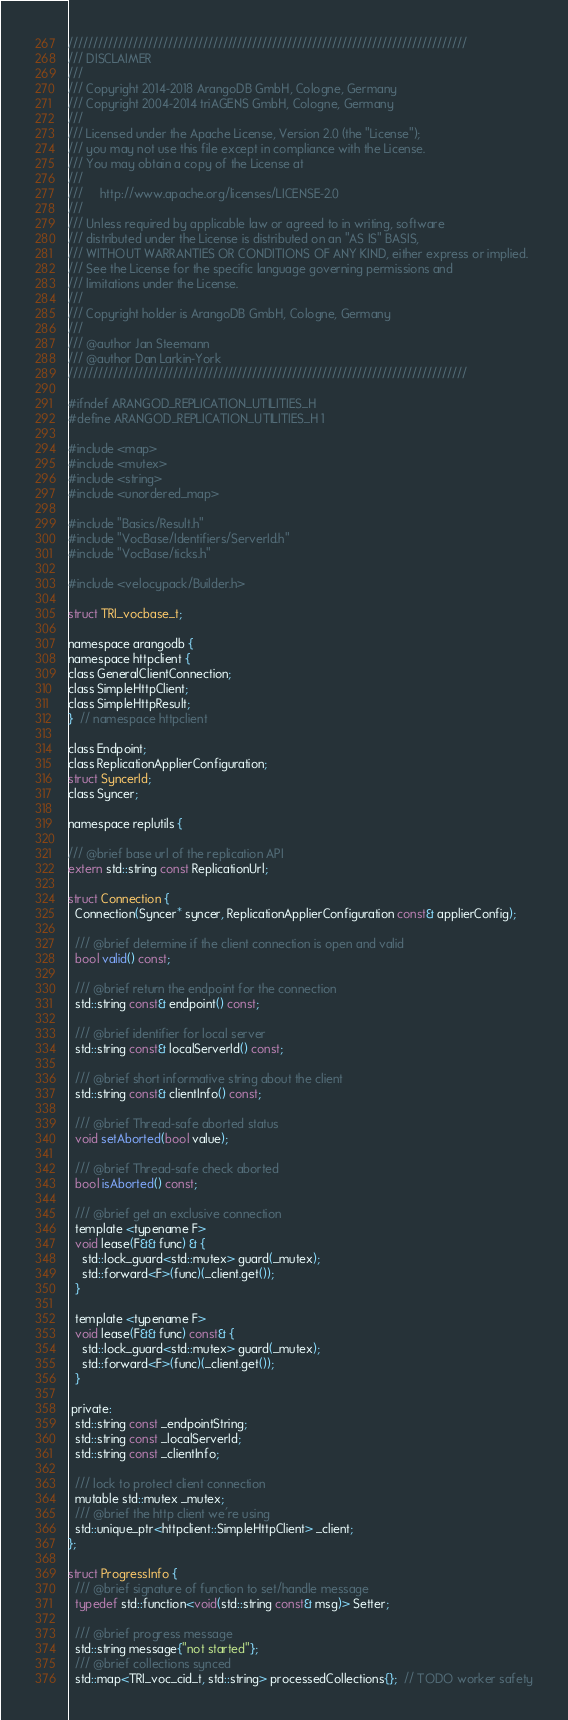Convert code to text. <code><loc_0><loc_0><loc_500><loc_500><_C_>////////////////////////////////////////////////////////////////////////////////
/// DISCLAIMER
///
/// Copyright 2014-2018 ArangoDB GmbH, Cologne, Germany
/// Copyright 2004-2014 triAGENS GmbH, Cologne, Germany
///
/// Licensed under the Apache License, Version 2.0 (the "License");
/// you may not use this file except in compliance with the License.
/// You may obtain a copy of the License at
///
///     http://www.apache.org/licenses/LICENSE-2.0
///
/// Unless required by applicable law or agreed to in writing, software
/// distributed under the License is distributed on an "AS IS" BASIS,
/// WITHOUT WARRANTIES OR CONDITIONS OF ANY KIND, either express or implied.
/// See the License for the specific language governing permissions and
/// limitations under the License.
///
/// Copyright holder is ArangoDB GmbH, Cologne, Germany
///
/// @author Jan Steemann
/// @author Dan Larkin-York
////////////////////////////////////////////////////////////////////////////////

#ifndef ARANGOD_REPLICATION_UTILITIES_H
#define ARANGOD_REPLICATION_UTILITIES_H 1

#include <map>
#include <mutex>
#include <string>
#include <unordered_map>

#include "Basics/Result.h"
#include "VocBase/Identifiers/ServerId.h"
#include "VocBase/ticks.h"

#include <velocypack/Builder.h>

struct TRI_vocbase_t;

namespace arangodb {
namespace httpclient {
class GeneralClientConnection;
class SimpleHttpClient;
class SimpleHttpResult;
}  // namespace httpclient

class Endpoint;
class ReplicationApplierConfiguration;
struct SyncerId;
class Syncer;

namespace replutils {

/// @brief base url of the replication API
extern std::string const ReplicationUrl;

struct Connection {
  Connection(Syncer* syncer, ReplicationApplierConfiguration const& applierConfig);

  /// @brief determine if the client connection is open and valid
  bool valid() const;

  /// @brief return the endpoint for the connection
  std::string const& endpoint() const;

  /// @brief identifier for local server
  std::string const& localServerId() const;

  /// @brief short informative string about the client
  std::string const& clientInfo() const;

  /// @brief Thread-safe aborted status
  void setAborted(bool value);

  /// @brief Thread-safe check aborted
  bool isAborted() const;

  /// @brief get an exclusive connection
  template <typename F>
  void lease(F&& func) & {
    std::lock_guard<std::mutex> guard(_mutex);
    std::forward<F>(func)(_client.get());
  }

  template <typename F>
  void lease(F&& func) const& {
    std::lock_guard<std::mutex> guard(_mutex);
    std::forward<F>(func)(_client.get());
  }

 private:
  std::string const _endpointString;
  std::string const _localServerId;
  std::string const _clientInfo;

  /// lock to protect client connection
  mutable std::mutex _mutex;
  /// @brief the http client we're using
  std::unique_ptr<httpclient::SimpleHttpClient> _client;
};

struct ProgressInfo {
  /// @brief signature of function to set/handle message
  typedef std::function<void(std::string const& msg)> Setter;

  /// @brief progress message
  std::string message{"not started"};
  /// @brief collections synced
  std::map<TRI_voc_cid_t, std::string> processedCollections{};  // TODO worker safety
</code> 